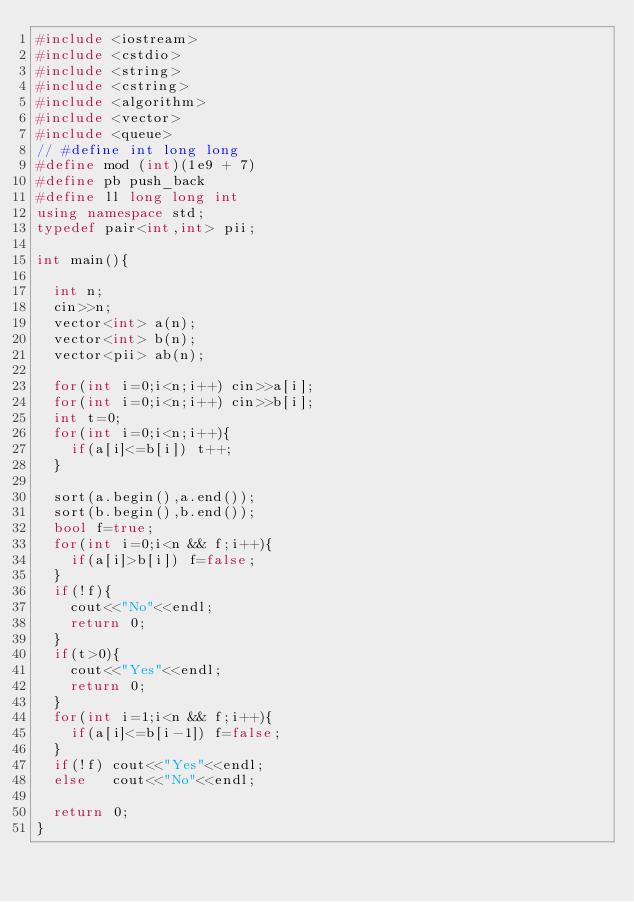<code> <loc_0><loc_0><loc_500><loc_500><_C++_>#include <iostream>
#include <cstdio>
#include <string>
#include <cstring>
#include <algorithm>
#include <vector>
#include <queue>
// #define int long long
#define mod (int)(1e9 + 7)
#define pb push_back
#define ll long long int
using namespace std;
typedef pair<int,int> pii;

int main(){

  int n;
  cin>>n;
  vector<int> a(n);
  vector<int> b(n);
  vector<pii> ab(n);
  
  for(int i=0;i<n;i++) cin>>a[i];
  for(int i=0;i<n;i++) cin>>b[i];
  int t=0;
  for(int i=0;i<n;i++){
    if(a[i]<=b[i]) t++;
  }
  
  sort(a.begin(),a.end());
  sort(b.begin(),b.end());
  bool f=true;
  for(int i=0;i<n && f;i++){
    if(a[i]>b[i]) f=false;
  }
  if(!f){
    cout<<"No"<<endl;
    return 0;
  }
  if(t>0){
    cout<<"Yes"<<endl;
    return 0;
  }
  for(int i=1;i<n && f;i++){
    if(a[i]<=b[i-1]) f=false;
  }
  if(!f) cout<<"Yes"<<endl;
  else   cout<<"No"<<endl;
  
  return 0;
}
</code> 